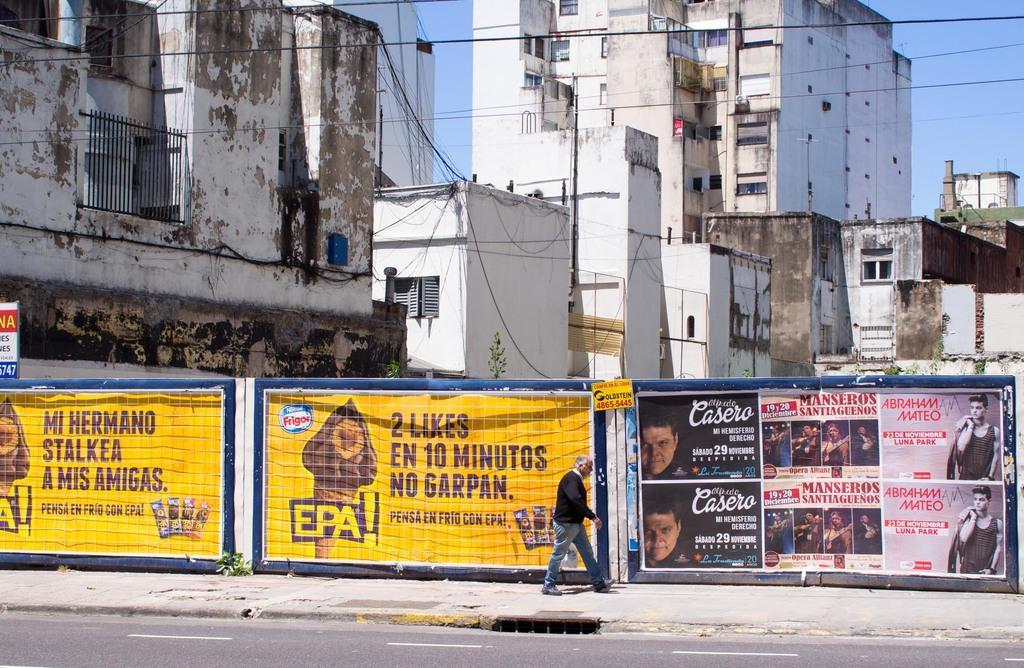Can you describe this image briefly? In the picture we can see a man walking along the footpath, there are some posters which are attached to the wall and in the background of the picture there are some buildings, wires and top of the picture there is clear sky. 